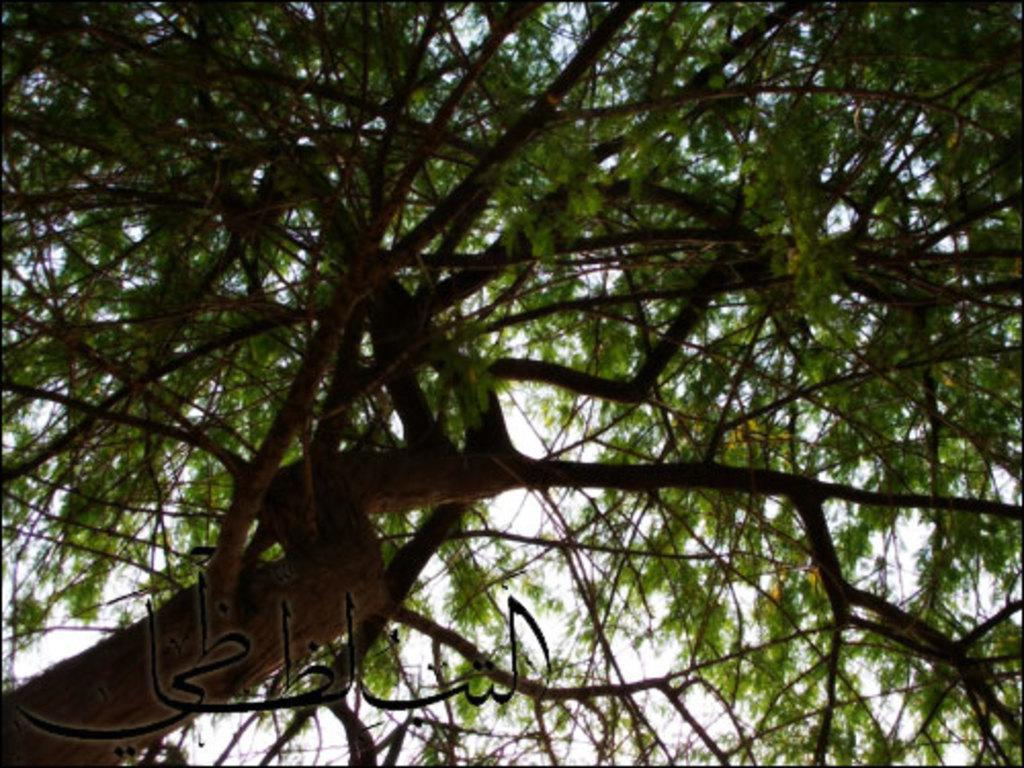What is the main subject of the image? The main subject of the image is a tree. How close is the camera to the tree in the image? The image is a zoomed-in picture of the tree. Is there any text visible in the image? Yes, there is text at the bottom of the image. Can you see any cords hanging from the tree in the image? There are no cords visible in the image; it only features a tree and text at the bottom. How many boys are playing on the boat in the image? There is no boat or boys present in the image; it only features a tree and text at the bottom. 